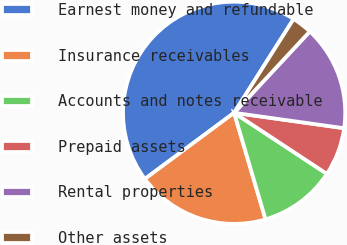<chart> <loc_0><loc_0><loc_500><loc_500><pie_chart><fcel>Earnest money and refundable<fcel>Insurance receivables<fcel>Accounts and notes receivable<fcel>Prepaid assets<fcel>Rental properties<fcel>Other assets<nl><fcel>44.15%<fcel>19.41%<fcel>11.17%<fcel>7.05%<fcel>15.29%<fcel>2.93%<nl></chart> 